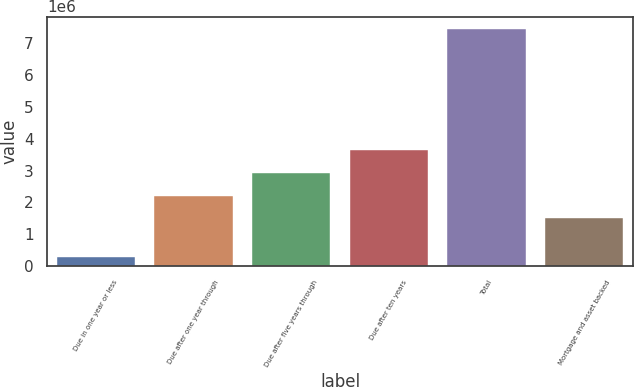Convert chart to OTSL. <chart><loc_0><loc_0><loc_500><loc_500><bar_chart><fcel>Due in one year or less<fcel>Due after one year through<fcel>Due after five years through<fcel>Due after ten years<fcel>Total<fcel>Mortgage and asset backed<nl><fcel>287038<fcel>2.21089e+06<fcel>2.9291e+06<fcel>3.6473e+06<fcel>7.46909e+06<fcel>1.49268e+06<nl></chart> 